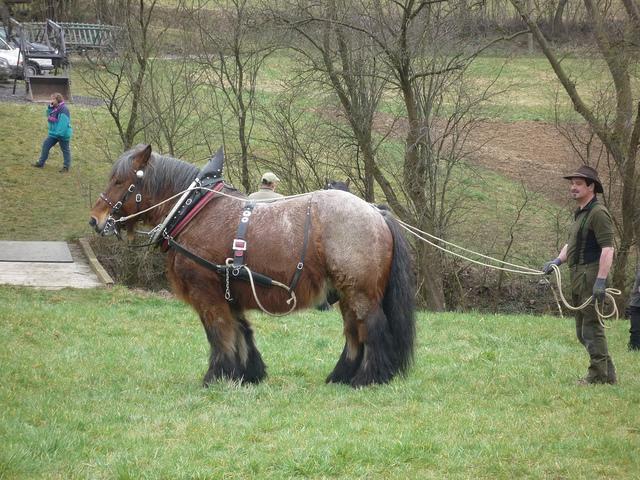How many ponies is this man standing behind?
Give a very brief answer. 1. How many people on the bike on the left?
Give a very brief answer. 0. 